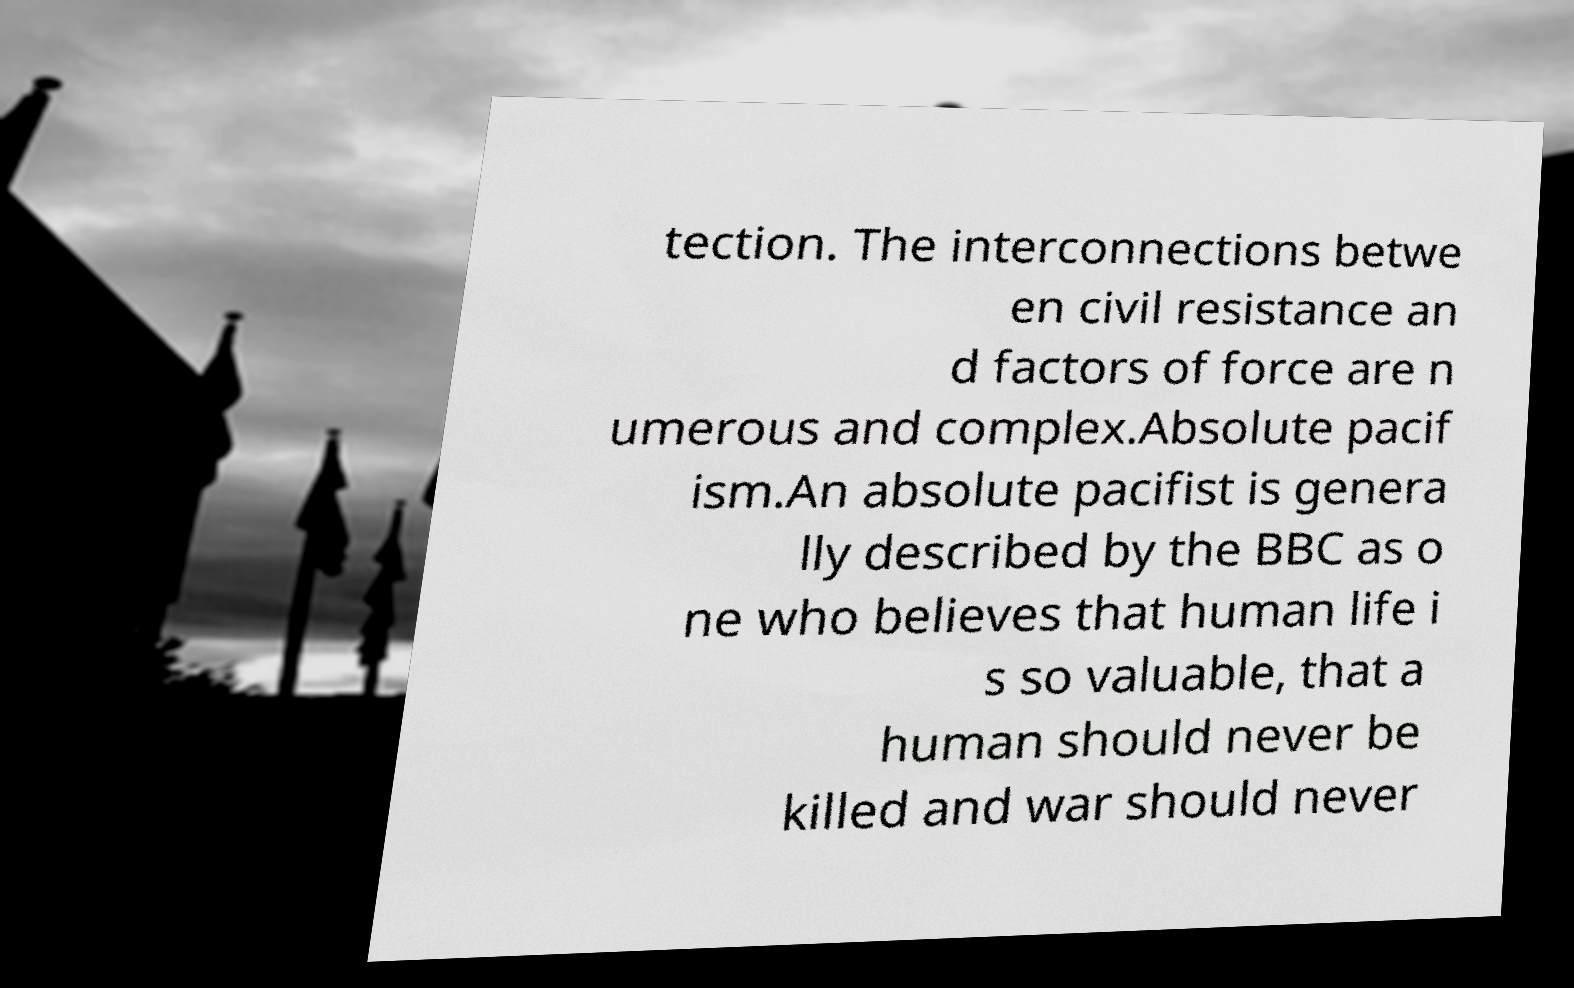Could you extract and type out the text from this image? tection. The interconnections betwe en civil resistance an d factors of force are n umerous and complex.Absolute pacif ism.An absolute pacifist is genera lly described by the BBC as o ne who believes that human life i s so valuable, that a human should never be killed and war should never 